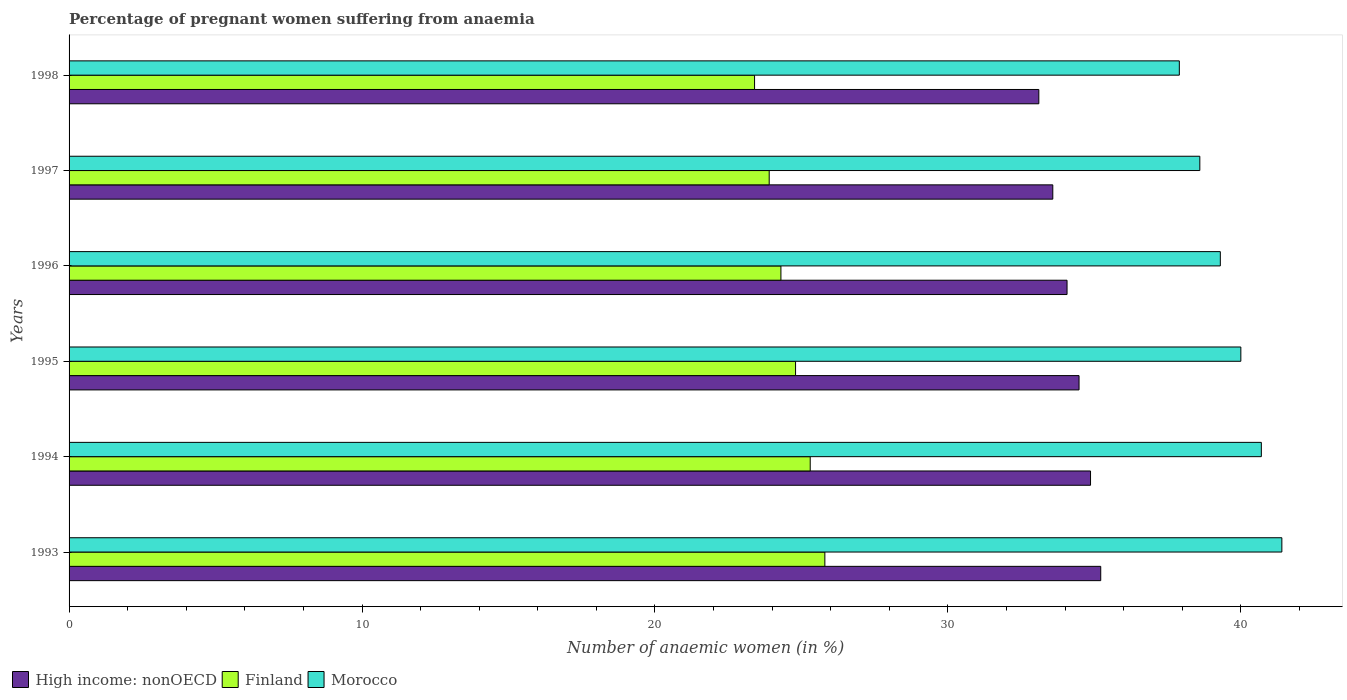How many different coloured bars are there?
Provide a succinct answer. 3. Are the number of bars per tick equal to the number of legend labels?
Offer a terse response. Yes. What is the label of the 5th group of bars from the top?
Make the answer very short. 1994. What is the number of anaemic women in Morocco in 1996?
Make the answer very short. 39.3. Across all years, what is the maximum number of anaemic women in Morocco?
Offer a very short reply. 41.4. Across all years, what is the minimum number of anaemic women in Finland?
Offer a very short reply. 23.4. In which year was the number of anaemic women in High income: nonOECD maximum?
Offer a very short reply. 1993. What is the total number of anaemic women in Morocco in the graph?
Make the answer very short. 237.9. What is the difference between the number of anaemic women in Morocco in 1994 and that in 1997?
Your answer should be very brief. 2.1. What is the difference between the number of anaemic women in High income: nonOECD in 1993 and the number of anaemic women in Finland in 1997?
Ensure brevity in your answer.  11.32. What is the average number of anaemic women in High income: nonOECD per year?
Offer a terse response. 34.22. In the year 1995, what is the difference between the number of anaemic women in Morocco and number of anaemic women in High income: nonOECD?
Offer a very short reply. 5.52. What is the ratio of the number of anaemic women in Morocco in 1996 to that in 1998?
Keep it short and to the point. 1.04. Is the number of anaemic women in Finland in 1994 less than that in 1997?
Keep it short and to the point. No. What is the difference between the highest and the second highest number of anaemic women in High income: nonOECD?
Your response must be concise. 0.35. What is the difference between the highest and the lowest number of anaemic women in Finland?
Provide a short and direct response. 2.4. In how many years, is the number of anaemic women in Morocco greater than the average number of anaemic women in Morocco taken over all years?
Your response must be concise. 3. What does the 3rd bar from the bottom in 1994 represents?
Provide a succinct answer. Morocco. How many bars are there?
Keep it short and to the point. 18. How many years are there in the graph?
Your answer should be very brief. 6. What is the difference between two consecutive major ticks on the X-axis?
Offer a terse response. 10. Are the values on the major ticks of X-axis written in scientific E-notation?
Provide a short and direct response. No. Does the graph contain any zero values?
Offer a very short reply. No. Does the graph contain grids?
Give a very brief answer. No. Where does the legend appear in the graph?
Your answer should be compact. Bottom left. How are the legend labels stacked?
Provide a short and direct response. Horizontal. What is the title of the graph?
Ensure brevity in your answer.  Percentage of pregnant women suffering from anaemia. What is the label or title of the X-axis?
Keep it short and to the point. Number of anaemic women (in %). What is the label or title of the Y-axis?
Your answer should be compact. Years. What is the Number of anaemic women (in %) of High income: nonOECD in 1993?
Ensure brevity in your answer.  35.22. What is the Number of anaemic women (in %) in Finland in 1993?
Your response must be concise. 25.8. What is the Number of anaemic women (in %) of Morocco in 1993?
Keep it short and to the point. 41.4. What is the Number of anaemic women (in %) in High income: nonOECD in 1994?
Your answer should be very brief. 34.87. What is the Number of anaemic women (in %) of Finland in 1994?
Ensure brevity in your answer.  25.3. What is the Number of anaemic women (in %) in Morocco in 1994?
Offer a very short reply. 40.7. What is the Number of anaemic women (in %) in High income: nonOECD in 1995?
Your answer should be very brief. 34.48. What is the Number of anaemic women (in %) of Finland in 1995?
Offer a very short reply. 24.8. What is the Number of anaemic women (in %) in High income: nonOECD in 1996?
Give a very brief answer. 34.07. What is the Number of anaemic women (in %) of Finland in 1996?
Offer a very short reply. 24.3. What is the Number of anaemic women (in %) in Morocco in 1996?
Keep it short and to the point. 39.3. What is the Number of anaemic women (in %) in High income: nonOECD in 1997?
Ensure brevity in your answer.  33.58. What is the Number of anaemic women (in %) of Finland in 1997?
Offer a terse response. 23.9. What is the Number of anaemic women (in %) of Morocco in 1997?
Provide a short and direct response. 38.6. What is the Number of anaemic women (in %) of High income: nonOECD in 1998?
Keep it short and to the point. 33.1. What is the Number of anaemic women (in %) of Finland in 1998?
Keep it short and to the point. 23.4. What is the Number of anaemic women (in %) in Morocco in 1998?
Offer a very short reply. 37.9. Across all years, what is the maximum Number of anaemic women (in %) of High income: nonOECD?
Provide a short and direct response. 35.22. Across all years, what is the maximum Number of anaemic women (in %) of Finland?
Keep it short and to the point. 25.8. Across all years, what is the maximum Number of anaemic women (in %) in Morocco?
Offer a very short reply. 41.4. Across all years, what is the minimum Number of anaemic women (in %) of High income: nonOECD?
Your answer should be compact. 33.1. Across all years, what is the minimum Number of anaemic women (in %) in Finland?
Your response must be concise. 23.4. Across all years, what is the minimum Number of anaemic women (in %) of Morocco?
Make the answer very short. 37.9. What is the total Number of anaemic women (in %) in High income: nonOECD in the graph?
Your response must be concise. 205.31. What is the total Number of anaemic women (in %) in Finland in the graph?
Make the answer very short. 147.5. What is the total Number of anaemic women (in %) of Morocco in the graph?
Make the answer very short. 237.9. What is the difference between the Number of anaemic women (in %) of High income: nonOECD in 1993 and that in 1994?
Provide a short and direct response. 0.35. What is the difference between the Number of anaemic women (in %) of Morocco in 1993 and that in 1994?
Make the answer very short. 0.7. What is the difference between the Number of anaemic women (in %) in High income: nonOECD in 1993 and that in 1995?
Your answer should be compact. 0.74. What is the difference between the Number of anaemic women (in %) in High income: nonOECD in 1993 and that in 1996?
Give a very brief answer. 1.15. What is the difference between the Number of anaemic women (in %) in Finland in 1993 and that in 1996?
Make the answer very short. 1.5. What is the difference between the Number of anaemic women (in %) in Morocco in 1993 and that in 1996?
Ensure brevity in your answer.  2.1. What is the difference between the Number of anaemic women (in %) of High income: nonOECD in 1993 and that in 1997?
Your response must be concise. 1.64. What is the difference between the Number of anaemic women (in %) in Finland in 1993 and that in 1997?
Your answer should be compact. 1.9. What is the difference between the Number of anaemic women (in %) of Morocco in 1993 and that in 1997?
Your answer should be compact. 2.8. What is the difference between the Number of anaemic women (in %) in High income: nonOECD in 1993 and that in 1998?
Your response must be concise. 2.11. What is the difference between the Number of anaemic women (in %) in Morocco in 1993 and that in 1998?
Offer a very short reply. 3.5. What is the difference between the Number of anaemic women (in %) of High income: nonOECD in 1994 and that in 1995?
Make the answer very short. 0.39. What is the difference between the Number of anaemic women (in %) in Morocco in 1994 and that in 1995?
Your answer should be very brief. 0.7. What is the difference between the Number of anaemic women (in %) in High income: nonOECD in 1994 and that in 1996?
Provide a short and direct response. 0.8. What is the difference between the Number of anaemic women (in %) in High income: nonOECD in 1994 and that in 1997?
Make the answer very short. 1.29. What is the difference between the Number of anaemic women (in %) of Morocco in 1994 and that in 1997?
Offer a terse response. 2.1. What is the difference between the Number of anaemic women (in %) in High income: nonOECD in 1994 and that in 1998?
Your answer should be compact. 1.76. What is the difference between the Number of anaemic women (in %) of Morocco in 1994 and that in 1998?
Ensure brevity in your answer.  2.8. What is the difference between the Number of anaemic women (in %) in High income: nonOECD in 1995 and that in 1996?
Your answer should be very brief. 0.41. What is the difference between the Number of anaemic women (in %) of Morocco in 1995 and that in 1996?
Keep it short and to the point. 0.7. What is the difference between the Number of anaemic women (in %) in High income: nonOECD in 1995 and that in 1997?
Your answer should be compact. 0.9. What is the difference between the Number of anaemic women (in %) of Finland in 1995 and that in 1997?
Offer a terse response. 0.9. What is the difference between the Number of anaemic women (in %) of Morocco in 1995 and that in 1997?
Your answer should be very brief. 1.4. What is the difference between the Number of anaemic women (in %) in High income: nonOECD in 1995 and that in 1998?
Ensure brevity in your answer.  1.37. What is the difference between the Number of anaemic women (in %) in Morocco in 1995 and that in 1998?
Give a very brief answer. 2.1. What is the difference between the Number of anaemic women (in %) of High income: nonOECD in 1996 and that in 1997?
Offer a very short reply. 0.49. What is the difference between the Number of anaemic women (in %) of Morocco in 1996 and that in 1997?
Make the answer very short. 0.7. What is the difference between the Number of anaemic women (in %) of High income: nonOECD in 1996 and that in 1998?
Provide a succinct answer. 0.96. What is the difference between the Number of anaemic women (in %) in Finland in 1996 and that in 1998?
Provide a succinct answer. 0.9. What is the difference between the Number of anaemic women (in %) of High income: nonOECD in 1997 and that in 1998?
Provide a short and direct response. 0.48. What is the difference between the Number of anaemic women (in %) in Finland in 1997 and that in 1998?
Provide a short and direct response. 0.5. What is the difference between the Number of anaemic women (in %) of Morocco in 1997 and that in 1998?
Offer a terse response. 0.7. What is the difference between the Number of anaemic women (in %) of High income: nonOECD in 1993 and the Number of anaemic women (in %) of Finland in 1994?
Give a very brief answer. 9.92. What is the difference between the Number of anaemic women (in %) in High income: nonOECD in 1993 and the Number of anaemic women (in %) in Morocco in 1994?
Give a very brief answer. -5.48. What is the difference between the Number of anaemic women (in %) in Finland in 1993 and the Number of anaemic women (in %) in Morocco in 1994?
Give a very brief answer. -14.9. What is the difference between the Number of anaemic women (in %) in High income: nonOECD in 1993 and the Number of anaemic women (in %) in Finland in 1995?
Keep it short and to the point. 10.42. What is the difference between the Number of anaemic women (in %) in High income: nonOECD in 1993 and the Number of anaemic women (in %) in Morocco in 1995?
Provide a short and direct response. -4.78. What is the difference between the Number of anaemic women (in %) of Finland in 1993 and the Number of anaemic women (in %) of Morocco in 1995?
Ensure brevity in your answer.  -14.2. What is the difference between the Number of anaemic women (in %) of High income: nonOECD in 1993 and the Number of anaemic women (in %) of Finland in 1996?
Your response must be concise. 10.92. What is the difference between the Number of anaemic women (in %) in High income: nonOECD in 1993 and the Number of anaemic women (in %) in Morocco in 1996?
Provide a succinct answer. -4.08. What is the difference between the Number of anaemic women (in %) of High income: nonOECD in 1993 and the Number of anaemic women (in %) of Finland in 1997?
Your answer should be compact. 11.32. What is the difference between the Number of anaemic women (in %) of High income: nonOECD in 1993 and the Number of anaemic women (in %) of Morocco in 1997?
Give a very brief answer. -3.38. What is the difference between the Number of anaemic women (in %) in Finland in 1993 and the Number of anaemic women (in %) in Morocco in 1997?
Your response must be concise. -12.8. What is the difference between the Number of anaemic women (in %) of High income: nonOECD in 1993 and the Number of anaemic women (in %) of Finland in 1998?
Provide a short and direct response. 11.82. What is the difference between the Number of anaemic women (in %) of High income: nonOECD in 1993 and the Number of anaemic women (in %) of Morocco in 1998?
Provide a short and direct response. -2.68. What is the difference between the Number of anaemic women (in %) of Finland in 1993 and the Number of anaemic women (in %) of Morocco in 1998?
Ensure brevity in your answer.  -12.1. What is the difference between the Number of anaemic women (in %) in High income: nonOECD in 1994 and the Number of anaemic women (in %) in Finland in 1995?
Your answer should be compact. 10.07. What is the difference between the Number of anaemic women (in %) in High income: nonOECD in 1994 and the Number of anaemic women (in %) in Morocco in 1995?
Give a very brief answer. -5.13. What is the difference between the Number of anaemic women (in %) of Finland in 1994 and the Number of anaemic women (in %) of Morocco in 1995?
Make the answer very short. -14.7. What is the difference between the Number of anaemic women (in %) in High income: nonOECD in 1994 and the Number of anaemic women (in %) in Finland in 1996?
Your answer should be compact. 10.57. What is the difference between the Number of anaemic women (in %) in High income: nonOECD in 1994 and the Number of anaemic women (in %) in Morocco in 1996?
Your answer should be compact. -4.43. What is the difference between the Number of anaemic women (in %) in High income: nonOECD in 1994 and the Number of anaemic women (in %) in Finland in 1997?
Provide a succinct answer. 10.97. What is the difference between the Number of anaemic women (in %) of High income: nonOECD in 1994 and the Number of anaemic women (in %) of Morocco in 1997?
Ensure brevity in your answer.  -3.73. What is the difference between the Number of anaemic women (in %) of High income: nonOECD in 1994 and the Number of anaemic women (in %) of Finland in 1998?
Your answer should be compact. 11.47. What is the difference between the Number of anaemic women (in %) in High income: nonOECD in 1994 and the Number of anaemic women (in %) in Morocco in 1998?
Keep it short and to the point. -3.03. What is the difference between the Number of anaemic women (in %) of High income: nonOECD in 1995 and the Number of anaemic women (in %) of Finland in 1996?
Offer a terse response. 10.18. What is the difference between the Number of anaemic women (in %) in High income: nonOECD in 1995 and the Number of anaemic women (in %) in Morocco in 1996?
Give a very brief answer. -4.82. What is the difference between the Number of anaemic women (in %) in Finland in 1995 and the Number of anaemic women (in %) in Morocco in 1996?
Your answer should be compact. -14.5. What is the difference between the Number of anaemic women (in %) of High income: nonOECD in 1995 and the Number of anaemic women (in %) of Finland in 1997?
Ensure brevity in your answer.  10.58. What is the difference between the Number of anaemic women (in %) in High income: nonOECD in 1995 and the Number of anaemic women (in %) in Morocco in 1997?
Provide a short and direct response. -4.12. What is the difference between the Number of anaemic women (in %) in High income: nonOECD in 1995 and the Number of anaemic women (in %) in Finland in 1998?
Your answer should be very brief. 11.08. What is the difference between the Number of anaemic women (in %) of High income: nonOECD in 1995 and the Number of anaemic women (in %) of Morocco in 1998?
Your response must be concise. -3.42. What is the difference between the Number of anaemic women (in %) in Finland in 1995 and the Number of anaemic women (in %) in Morocco in 1998?
Give a very brief answer. -13.1. What is the difference between the Number of anaemic women (in %) of High income: nonOECD in 1996 and the Number of anaemic women (in %) of Finland in 1997?
Offer a very short reply. 10.17. What is the difference between the Number of anaemic women (in %) in High income: nonOECD in 1996 and the Number of anaemic women (in %) in Morocco in 1997?
Provide a succinct answer. -4.53. What is the difference between the Number of anaemic women (in %) of Finland in 1996 and the Number of anaemic women (in %) of Morocco in 1997?
Offer a terse response. -14.3. What is the difference between the Number of anaemic women (in %) in High income: nonOECD in 1996 and the Number of anaemic women (in %) in Finland in 1998?
Offer a very short reply. 10.67. What is the difference between the Number of anaemic women (in %) of High income: nonOECD in 1996 and the Number of anaemic women (in %) of Morocco in 1998?
Your response must be concise. -3.83. What is the difference between the Number of anaemic women (in %) in High income: nonOECD in 1997 and the Number of anaemic women (in %) in Finland in 1998?
Your answer should be very brief. 10.18. What is the difference between the Number of anaemic women (in %) in High income: nonOECD in 1997 and the Number of anaemic women (in %) in Morocco in 1998?
Your answer should be compact. -4.32. What is the difference between the Number of anaemic women (in %) of Finland in 1997 and the Number of anaemic women (in %) of Morocco in 1998?
Make the answer very short. -14. What is the average Number of anaemic women (in %) of High income: nonOECD per year?
Provide a succinct answer. 34.22. What is the average Number of anaemic women (in %) of Finland per year?
Your answer should be very brief. 24.58. What is the average Number of anaemic women (in %) of Morocco per year?
Make the answer very short. 39.65. In the year 1993, what is the difference between the Number of anaemic women (in %) of High income: nonOECD and Number of anaemic women (in %) of Finland?
Make the answer very short. 9.42. In the year 1993, what is the difference between the Number of anaemic women (in %) of High income: nonOECD and Number of anaemic women (in %) of Morocco?
Your response must be concise. -6.18. In the year 1993, what is the difference between the Number of anaemic women (in %) of Finland and Number of anaemic women (in %) of Morocco?
Ensure brevity in your answer.  -15.6. In the year 1994, what is the difference between the Number of anaemic women (in %) of High income: nonOECD and Number of anaemic women (in %) of Finland?
Offer a terse response. 9.57. In the year 1994, what is the difference between the Number of anaemic women (in %) in High income: nonOECD and Number of anaemic women (in %) in Morocco?
Your answer should be compact. -5.83. In the year 1994, what is the difference between the Number of anaemic women (in %) in Finland and Number of anaemic women (in %) in Morocco?
Make the answer very short. -15.4. In the year 1995, what is the difference between the Number of anaemic women (in %) of High income: nonOECD and Number of anaemic women (in %) of Finland?
Your answer should be compact. 9.68. In the year 1995, what is the difference between the Number of anaemic women (in %) in High income: nonOECD and Number of anaemic women (in %) in Morocco?
Ensure brevity in your answer.  -5.52. In the year 1995, what is the difference between the Number of anaemic women (in %) of Finland and Number of anaemic women (in %) of Morocco?
Offer a very short reply. -15.2. In the year 1996, what is the difference between the Number of anaemic women (in %) of High income: nonOECD and Number of anaemic women (in %) of Finland?
Your answer should be very brief. 9.77. In the year 1996, what is the difference between the Number of anaemic women (in %) of High income: nonOECD and Number of anaemic women (in %) of Morocco?
Your answer should be very brief. -5.23. In the year 1996, what is the difference between the Number of anaemic women (in %) in Finland and Number of anaemic women (in %) in Morocco?
Offer a terse response. -15. In the year 1997, what is the difference between the Number of anaemic women (in %) of High income: nonOECD and Number of anaemic women (in %) of Finland?
Ensure brevity in your answer.  9.68. In the year 1997, what is the difference between the Number of anaemic women (in %) in High income: nonOECD and Number of anaemic women (in %) in Morocco?
Give a very brief answer. -5.02. In the year 1997, what is the difference between the Number of anaemic women (in %) of Finland and Number of anaemic women (in %) of Morocco?
Make the answer very short. -14.7. In the year 1998, what is the difference between the Number of anaemic women (in %) in High income: nonOECD and Number of anaemic women (in %) in Finland?
Provide a short and direct response. 9.7. In the year 1998, what is the difference between the Number of anaemic women (in %) in High income: nonOECD and Number of anaemic women (in %) in Morocco?
Make the answer very short. -4.8. What is the ratio of the Number of anaemic women (in %) of Finland in 1993 to that in 1994?
Give a very brief answer. 1.02. What is the ratio of the Number of anaemic women (in %) of Morocco in 1993 to that in 1994?
Offer a very short reply. 1.02. What is the ratio of the Number of anaemic women (in %) in High income: nonOECD in 1993 to that in 1995?
Provide a short and direct response. 1.02. What is the ratio of the Number of anaemic women (in %) of Finland in 1993 to that in 1995?
Make the answer very short. 1.04. What is the ratio of the Number of anaemic women (in %) of Morocco in 1993 to that in 1995?
Offer a terse response. 1.03. What is the ratio of the Number of anaemic women (in %) in High income: nonOECD in 1993 to that in 1996?
Offer a very short reply. 1.03. What is the ratio of the Number of anaemic women (in %) in Finland in 1993 to that in 1996?
Ensure brevity in your answer.  1.06. What is the ratio of the Number of anaemic women (in %) of Morocco in 1993 to that in 1996?
Provide a succinct answer. 1.05. What is the ratio of the Number of anaemic women (in %) of High income: nonOECD in 1993 to that in 1997?
Offer a very short reply. 1.05. What is the ratio of the Number of anaemic women (in %) in Finland in 1993 to that in 1997?
Provide a short and direct response. 1.08. What is the ratio of the Number of anaemic women (in %) in Morocco in 1993 to that in 1997?
Your answer should be very brief. 1.07. What is the ratio of the Number of anaemic women (in %) in High income: nonOECD in 1993 to that in 1998?
Keep it short and to the point. 1.06. What is the ratio of the Number of anaemic women (in %) of Finland in 1993 to that in 1998?
Offer a very short reply. 1.1. What is the ratio of the Number of anaemic women (in %) in Morocco in 1993 to that in 1998?
Your answer should be very brief. 1.09. What is the ratio of the Number of anaemic women (in %) of High income: nonOECD in 1994 to that in 1995?
Offer a terse response. 1.01. What is the ratio of the Number of anaemic women (in %) in Finland in 1994 to that in 1995?
Offer a very short reply. 1.02. What is the ratio of the Number of anaemic women (in %) in Morocco in 1994 to that in 1995?
Make the answer very short. 1.02. What is the ratio of the Number of anaemic women (in %) of High income: nonOECD in 1994 to that in 1996?
Provide a short and direct response. 1.02. What is the ratio of the Number of anaemic women (in %) in Finland in 1994 to that in 1996?
Your answer should be very brief. 1.04. What is the ratio of the Number of anaemic women (in %) in Morocco in 1994 to that in 1996?
Offer a very short reply. 1.04. What is the ratio of the Number of anaemic women (in %) in High income: nonOECD in 1994 to that in 1997?
Your answer should be compact. 1.04. What is the ratio of the Number of anaemic women (in %) in Finland in 1994 to that in 1997?
Make the answer very short. 1.06. What is the ratio of the Number of anaemic women (in %) of Morocco in 1994 to that in 1997?
Ensure brevity in your answer.  1.05. What is the ratio of the Number of anaemic women (in %) in High income: nonOECD in 1994 to that in 1998?
Make the answer very short. 1.05. What is the ratio of the Number of anaemic women (in %) of Finland in 1994 to that in 1998?
Ensure brevity in your answer.  1.08. What is the ratio of the Number of anaemic women (in %) in Morocco in 1994 to that in 1998?
Your answer should be very brief. 1.07. What is the ratio of the Number of anaemic women (in %) in High income: nonOECD in 1995 to that in 1996?
Ensure brevity in your answer.  1.01. What is the ratio of the Number of anaemic women (in %) in Finland in 1995 to that in 1996?
Keep it short and to the point. 1.02. What is the ratio of the Number of anaemic women (in %) of Morocco in 1995 to that in 1996?
Give a very brief answer. 1.02. What is the ratio of the Number of anaemic women (in %) in High income: nonOECD in 1995 to that in 1997?
Your response must be concise. 1.03. What is the ratio of the Number of anaemic women (in %) in Finland in 1995 to that in 1997?
Your answer should be compact. 1.04. What is the ratio of the Number of anaemic women (in %) in Morocco in 1995 to that in 1997?
Your response must be concise. 1.04. What is the ratio of the Number of anaemic women (in %) in High income: nonOECD in 1995 to that in 1998?
Offer a very short reply. 1.04. What is the ratio of the Number of anaemic women (in %) in Finland in 1995 to that in 1998?
Your response must be concise. 1.06. What is the ratio of the Number of anaemic women (in %) in Morocco in 1995 to that in 1998?
Your response must be concise. 1.06. What is the ratio of the Number of anaemic women (in %) in High income: nonOECD in 1996 to that in 1997?
Provide a short and direct response. 1.01. What is the ratio of the Number of anaemic women (in %) of Finland in 1996 to that in 1997?
Give a very brief answer. 1.02. What is the ratio of the Number of anaemic women (in %) of Morocco in 1996 to that in 1997?
Offer a terse response. 1.02. What is the ratio of the Number of anaemic women (in %) of High income: nonOECD in 1996 to that in 1998?
Keep it short and to the point. 1.03. What is the ratio of the Number of anaemic women (in %) of Finland in 1996 to that in 1998?
Make the answer very short. 1.04. What is the ratio of the Number of anaemic women (in %) in Morocco in 1996 to that in 1998?
Give a very brief answer. 1.04. What is the ratio of the Number of anaemic women (in %) of High income: nonOECD in 1997 to that in 1998?
Provide a short and direct response. 1.01. What is the ratio of the Number of anaemic women (in %) of Finland in 1997 to that in 1998?
Your answer should be compact. 1.02. What is the ratio of the Number of anaemic women (in %) of Morocco in 1997 to that in 1998?
Ensure brevity in your answer.  1.02. What is the difference between the highest and the second highest Number of anaemic women (in %) in High income: nonOECD?
Offer a terse response. 0.35. What is the difference between the highest and the second highest Number of anaemic women (in %) of Finland?
Your response must be concise. 0.5. What is the difference between the highest and the second highest Number of anaemic women (in %) in Morocco?
Your answer should be compact. 0.7. What is the difference between the highest and the lowest Number of anaemic women (in %) in High income: nonOECD?
Your answer should be very brief. 2.11. What is the difference between the highest and the lowest Number of anaemic women (in %) of Finland?
Make the answer very short. 2.4. 